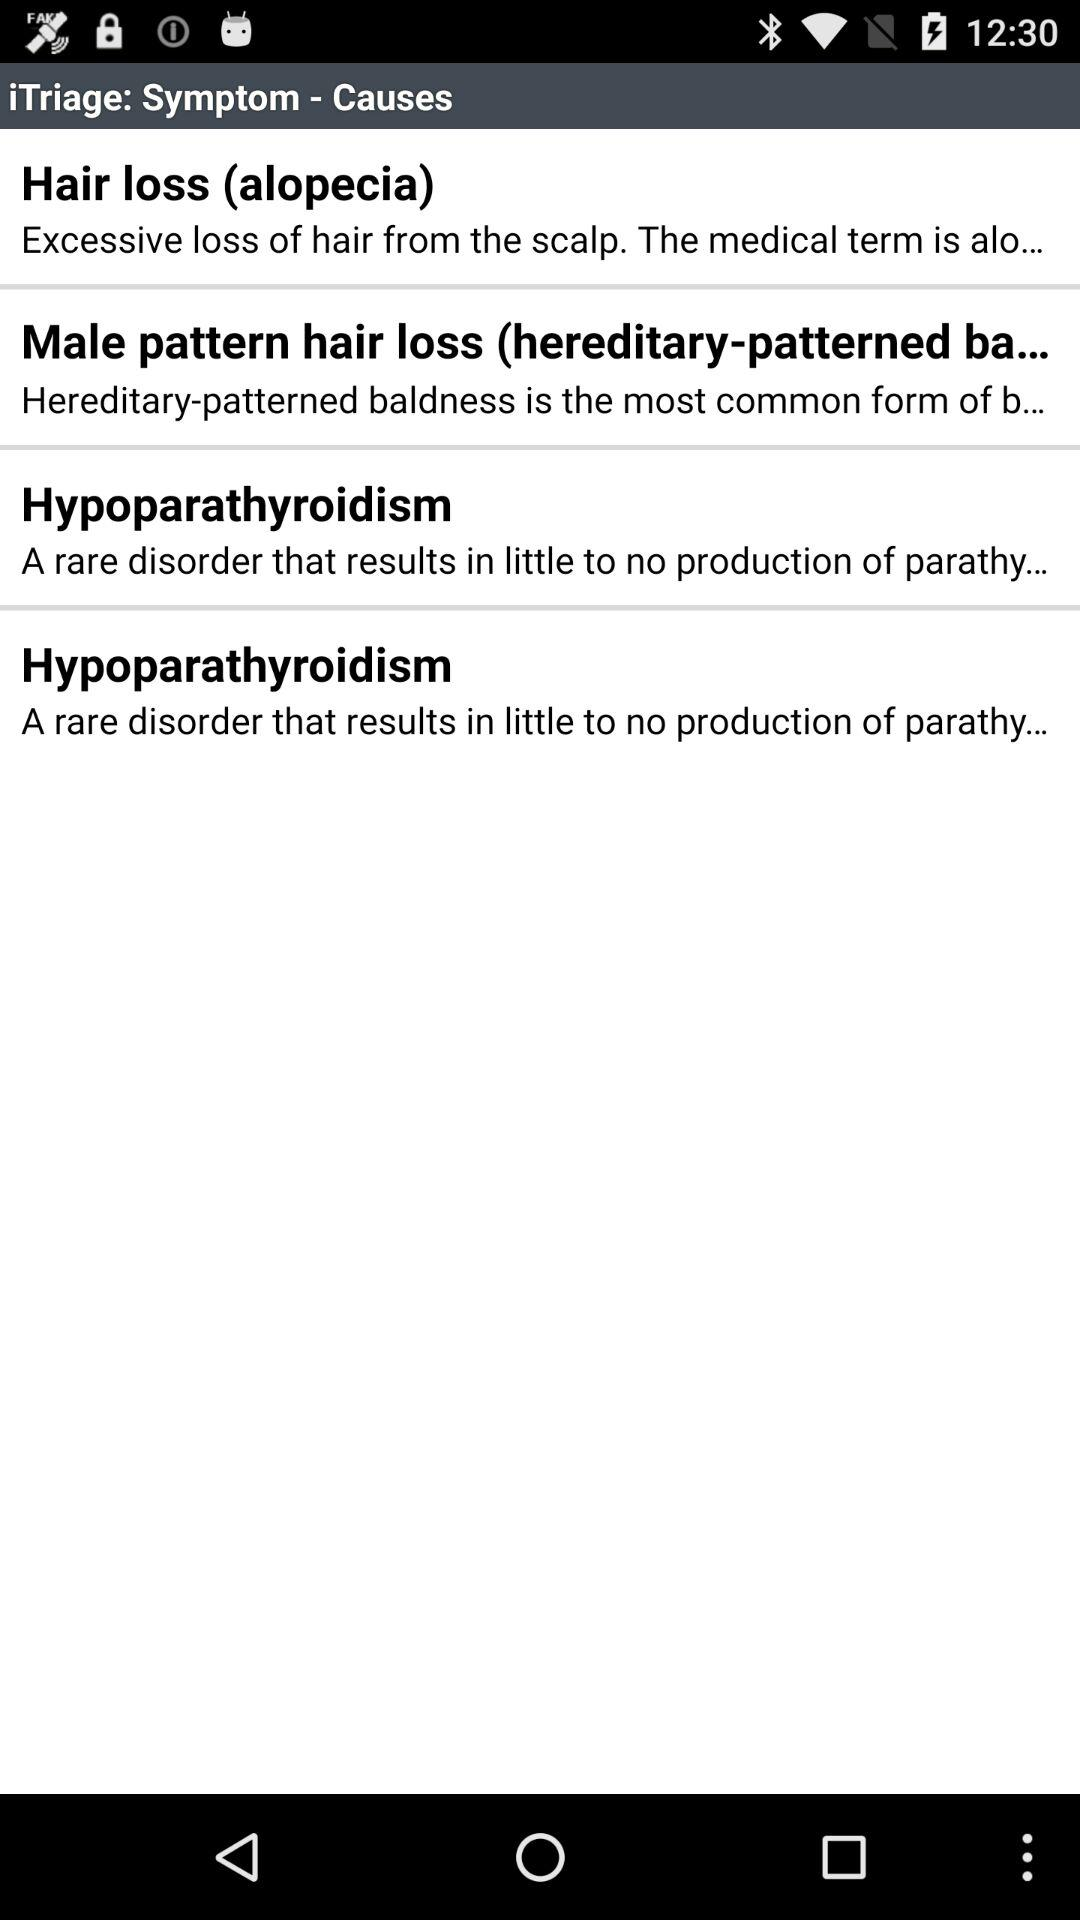Who is likely to contract hypoparathyroidism?
When the provided information is insufficient, respond with <no answer>. <no answer> 